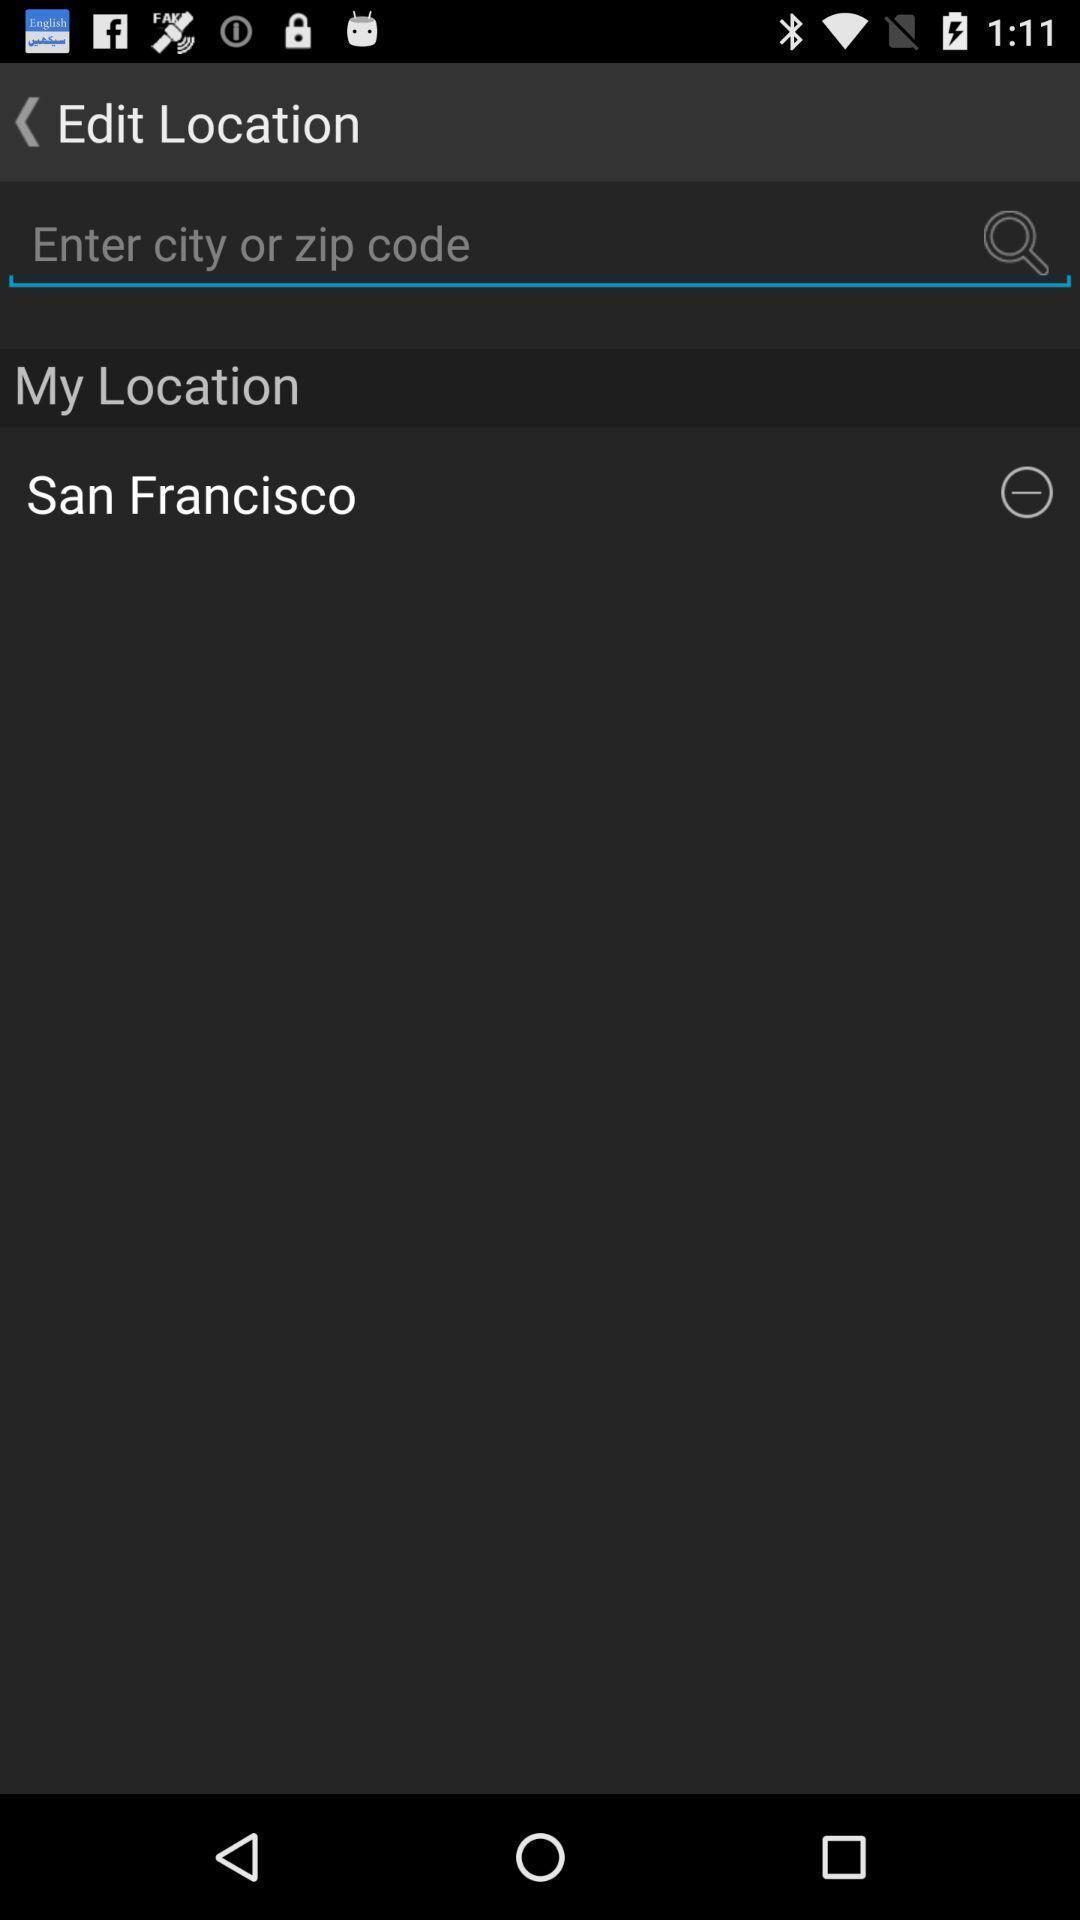Explain what's happening in this screen capture. Search bar to find location in weather application. 